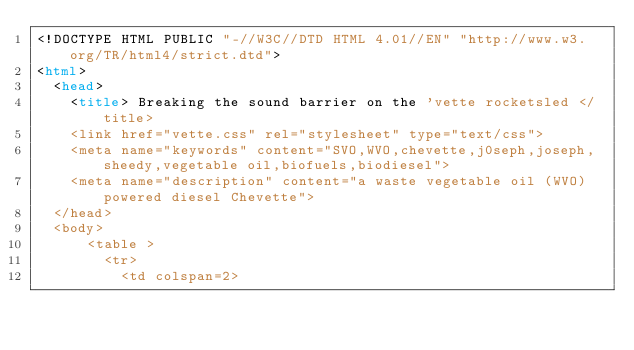Convert code to text. <code><loc_0><loc_0><loc_500><loc_500><_HTML_><!DOCTYPE HTML PUBLIC "-//W3C//DTD HTML 4.01//EN" "http://www.w3.org/TR/html4/strict.dtd">
<html>
	<head>
		<title> Breaking the sound barrier on the 'vette rocketsled </title>
		<link href="vette.css" rel="stylesheet" type="text/css">
		<meta name="keywords" content="SVO,WVO,chevette,j0seph,joseph,sheedy,vegetable oil,biofuels,biodiesel">
		<meta name="description" content="a waste vegetable oil (WVO) powered diesel Chevette">
	</head>
	<body>
			<table >
				<tr>
					<td colspan=2>
</code> 